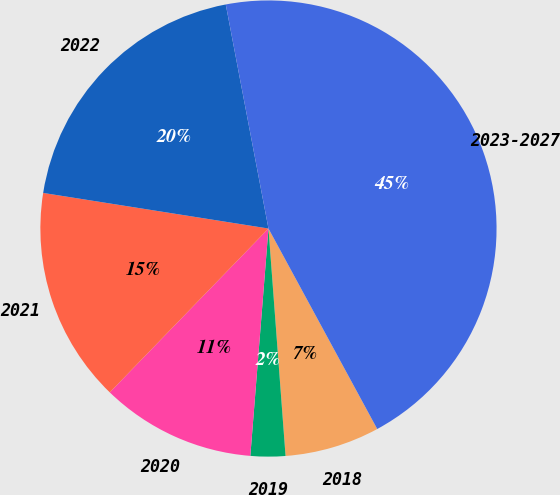Convert chart to OTSL. <chart><loc_0><loc_0><loc_500><loc_500><pie_chart><fcel>2018<fcel>2019<fcel>2020<fcel>2021<fcel>2022<fcel>2023-2027<nl><fcel>6.72%<fcel>2.46%<fcel>10.98%<fcel>15.25%<fcel>19.51%<fcel>45.09%<nl></chart> 